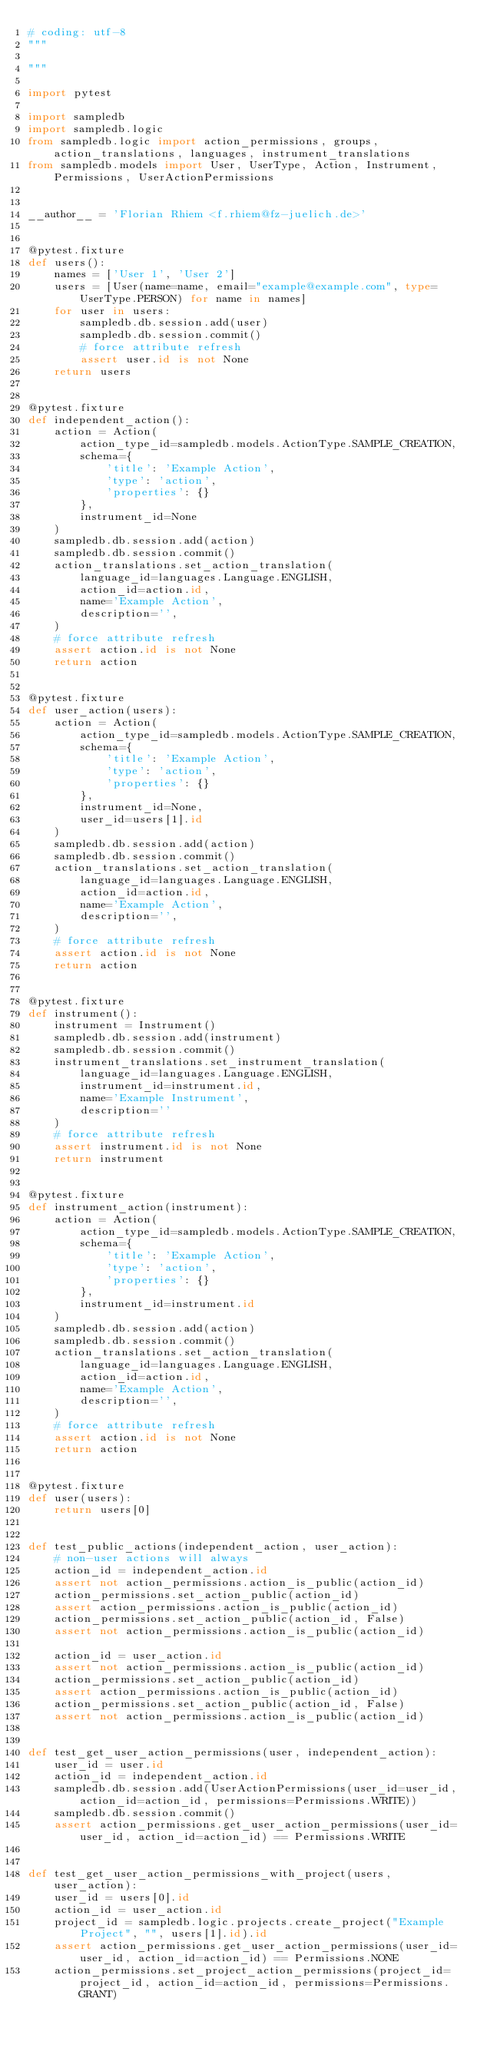<code> <loc_0><loc_0><loc_500><loc_500><_Python_># coding: utf-8
"""

"""

import pytest

import sampledb
import sampledb.logic
from sampledb.logic import action_permissions, groups, action_translations, languages, instrument_translations
from sampledb.models import User, UserType, Action, Instrument, Permissions, UserActionPermissions


__author__ = 'Florian Rhiem <f.rhiem@fz-juelich.de>'


@pytest.fixture
def users():
    names = ['User 1', 'User 2']
    users = [User(name=name, email="example@example.com", type=UserType.PERSON) for name in names]
    for user in users:
        sampledb.db.session.add(user)
        sampledb.db.session.commit()
        # force attribute refresh
        assert user.id is not None
    return users


@pytest.fixture
def independent_action():
    action = Action(
        action_type_id=sampledb.models.ActionType.SAMPLE_CREATION,
        schema={
            'title': 'Example Action',
            'type': 'action',
            'properties': {}
        },
        instrument_id=None
    )
    sampledb.db.session.add(action)
    sampledb.db.session.commit()
    action_translations.set_action_translation(
        language_id=languages.Language.ENGLISH,
        action_id=action.id,
        name='Example Action',
        description='',
    )
    # force attribute refresh
    assert action.id is not None
    return action


@pytest.fixture
def user_action(users):
    action = Action(
        action_type_id=sampledb.models.ActionType.SAMPLE_CREATION,
        schema={
            'title': 'Example Action',
            'type': 'action',
            'properties': {}
        },
        instrument_id=None,
        user_id=users[1].id
    )
    sampledb.db.session.add(action)
    sampledb.db.session.commit()
    action_translations.set_action_translation(
        language_id=languages.Language.ENGLISH,
        action_id=action.id,
        name='Example Action',
        description='',
    )
    # force attribute refresh
    assert action.id is not None
    return action


@pytest.fixture
def instrument():
    instrument = Instrument()
    sampledb.db.session.add(instrument)
    sampledb.db.session.commit()
    instrument_translations.set_instrument_translation(
        language_id=languages.Language.ENGLISH,
        instrument_id=instrument.id,
        name='Example Instrument',
        description=''
    )
    # force attribute refresh
    assert instrument.id is not None
    return instrument


@pytest.fixture
def instrument_action(instrument):
    action = Action(
        action_type_id=sampledb.models.ActionType.SAMPLE_CREATION,
        schema={
            'title': 'Example Action',
            'type': 'action',
            'properties': {}
        },
        instrument_id=instrument.id
    )
    sampledb.db.session.add(action)
    sampledb.db.session.commit()
    action_translations.set_action_translation(
        language_id=languages.Language.ENGLISH,
        action_id=action.id,
        name='Example Action',
        description='',
    )
    # force attribute refresh
    assert action.id is not None
    return action


@pytest.fixture
def user(users):
    return users[0]


def test_public_actions(independent_action, user_action):
    # non-user actions will always
    action_id = independent_action.id
    assert not action_permissions.action_is_public(action_id)
    action_permissions.set_action_public(action_id)
    assert action_permissions.action_is_public(action_id)
    action_permissions.set_action_public(action_id, False)
    assert not action_permissions.action_is_public(action_id)

    action_id = user_action.id
    assert not action_permissions.action_is_public(action_id)
    action_permissions.set_action_public(action_id)
    assert action_permissions.action_is_public(action_id)
    action_permissions.set_action_public(action_id, False)
    assert not action_permissions.action_is_public(action_id)


def test_get_user_action_permissions(user, independent_action):
    user_id = user.id
    action_id = independent_action.id
    sampledb.db.session.add(UserActionPermissions(user_id=user_id, action_id=action_id, permissions=Permissions.WRITE))
    sampledb.db.session.commit()
    assert action_permissions.get_user_action_permissions(user_id=user_id, action_id=action_id) == Permissions.WRITE


def test_get_user_action_permissions_with_project(users, user_action):
    user_id = users[0].id
    action_id = user_action.id
    project_id = sampledb.logic.projects.create_project("Example Project", "", users[1].id).id
    assert action_permissions.get_user_action_permissions(user_id=user_id, action_id=action_id) == Permissions.NONE
    action_permissions.set_project_action_permissions(project_id=project_id, action_id=action_id, permissions=Permissions.GRANT)</code> 